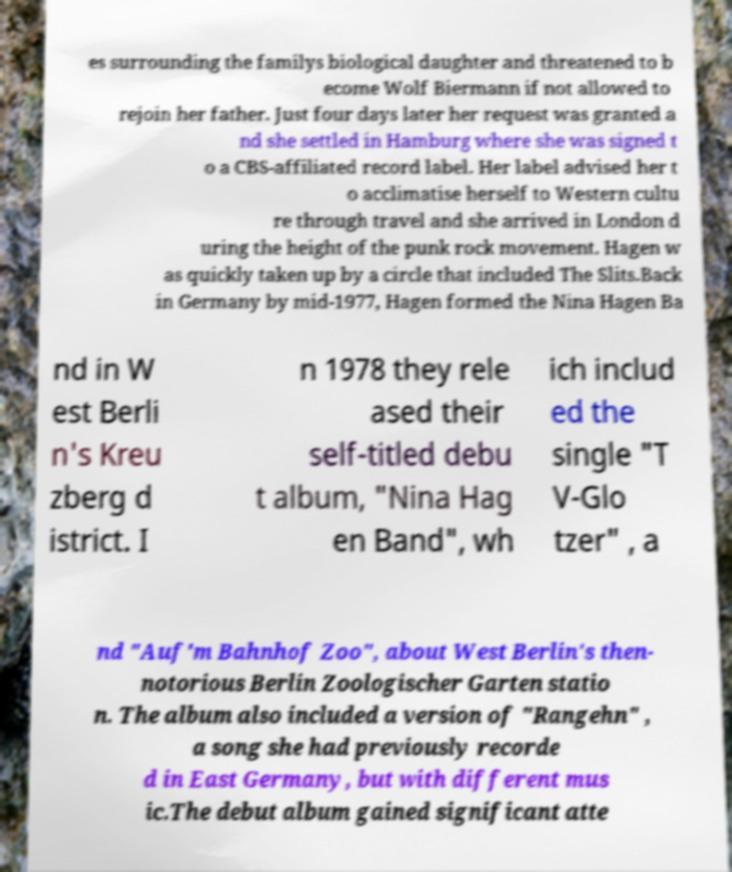I need the written content from this picture converted into text. Can you do that? es surrounding the familys biological daughter and threatened to b ecome Wolf Biermann if not allowed to rejoin her father. Just four days later her request was granted a nd she settled in Hamburg where she was signed t o a CBS-affiliated record label. Her label advised her t o acclimatise herself to Western cultu re through travel and she arrived in London d uring the height of the punk rock movement. Hagen w as quickly taken up by a circle that included The Slits.Back in Germany by mid-1977, Hagen formed the Nina Hagen Ba nd in W est Berli n's Kreu zberg d istrict. I n 1978 they rele ased their self-titled debu t album, "Nina Hag en Band", wh ich includ ed the single "T V-Glo tzer" , a nd "Auf'm Bahnhof Zoo", about West Berlin's then- notorious Berlin Zoologischer Garten statio n. The album also included a version of "Rangehn" , a song she had previously recorde d in East Germany, but with different mus ic.The debut album gained significant atte 